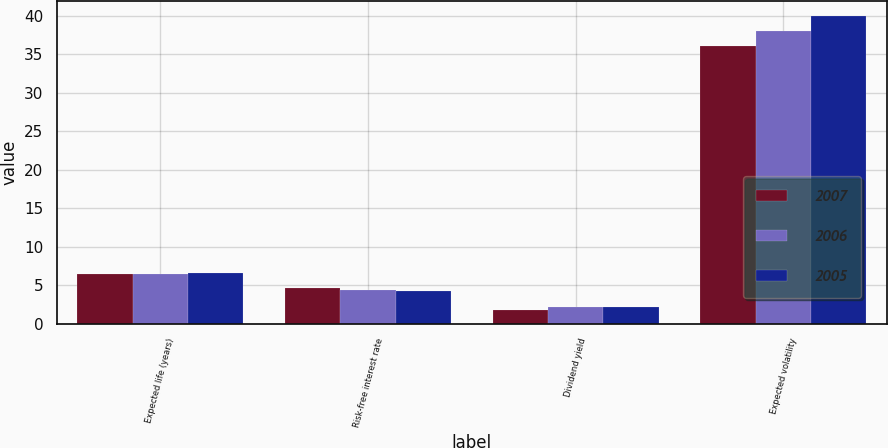Convert chart. <chart><loc_0><loc_0><loc_500><loc_500><stacked_bar_chart><ecel><fcel>Expected life (years)<fcel>Risk-free interest rate<fcel>Dividend yield<fcel>Expected volatility<nl><fcel>2007<fcel>6.5<fcel>4.7<fcel>1.8<fcel>36<nl><fcel>2006<fcel>6.4<fcel>4.4<fcel>2.2<fcel>38<nl><fcel>2005<fcel>6.6<fcel>4.2<fcel>2.2<fcel>39.9<nl></chart> 